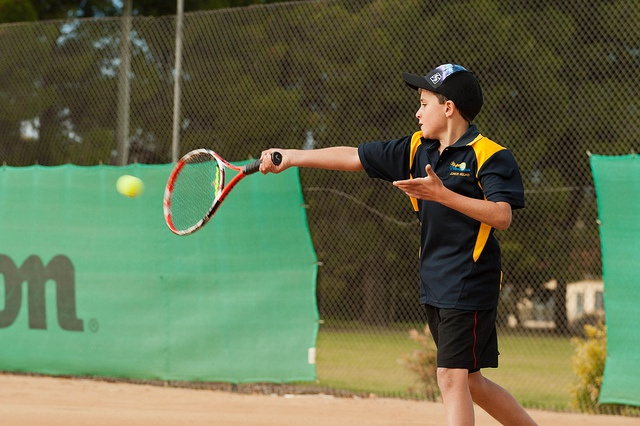Describe the objects in this image and their specific colors. I can see people in darkgreen, black, brown, and tan tones, tennis racket in darkgreen, green, turquoise, lightgray, and black tones, and sports ball in darkgreen, khaki, and lightgreen tones in this image. 